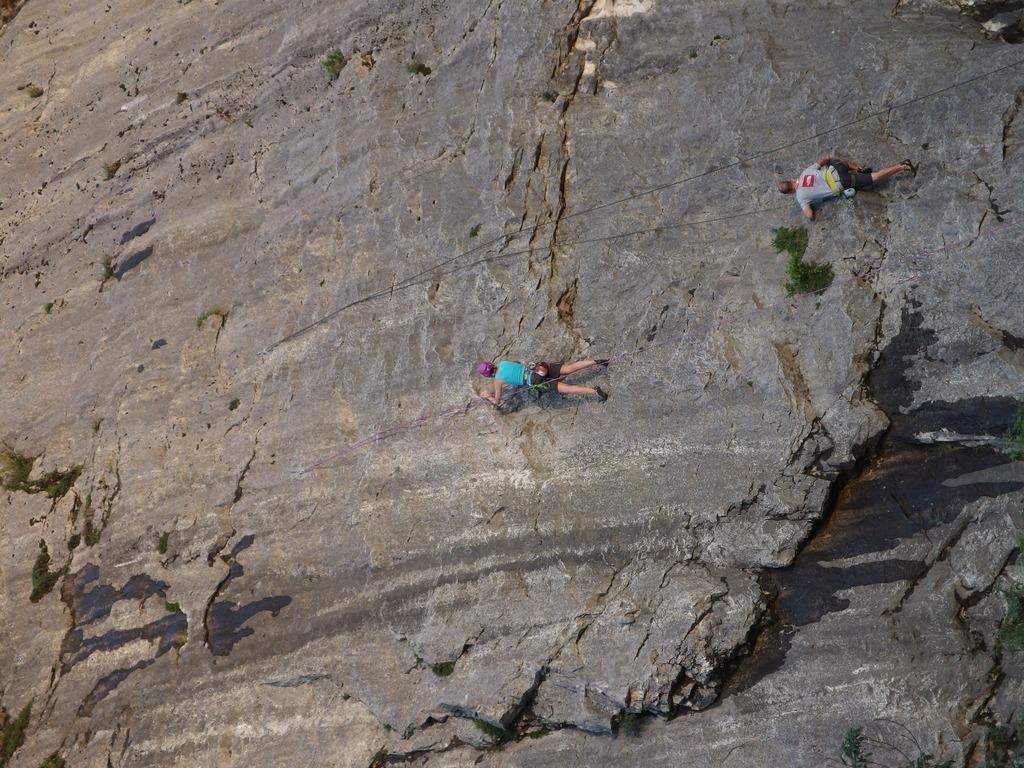Can you describe this image briefly? In this image we can see these two persons trekking on the rock hill using ropes. Here we can see the water. 